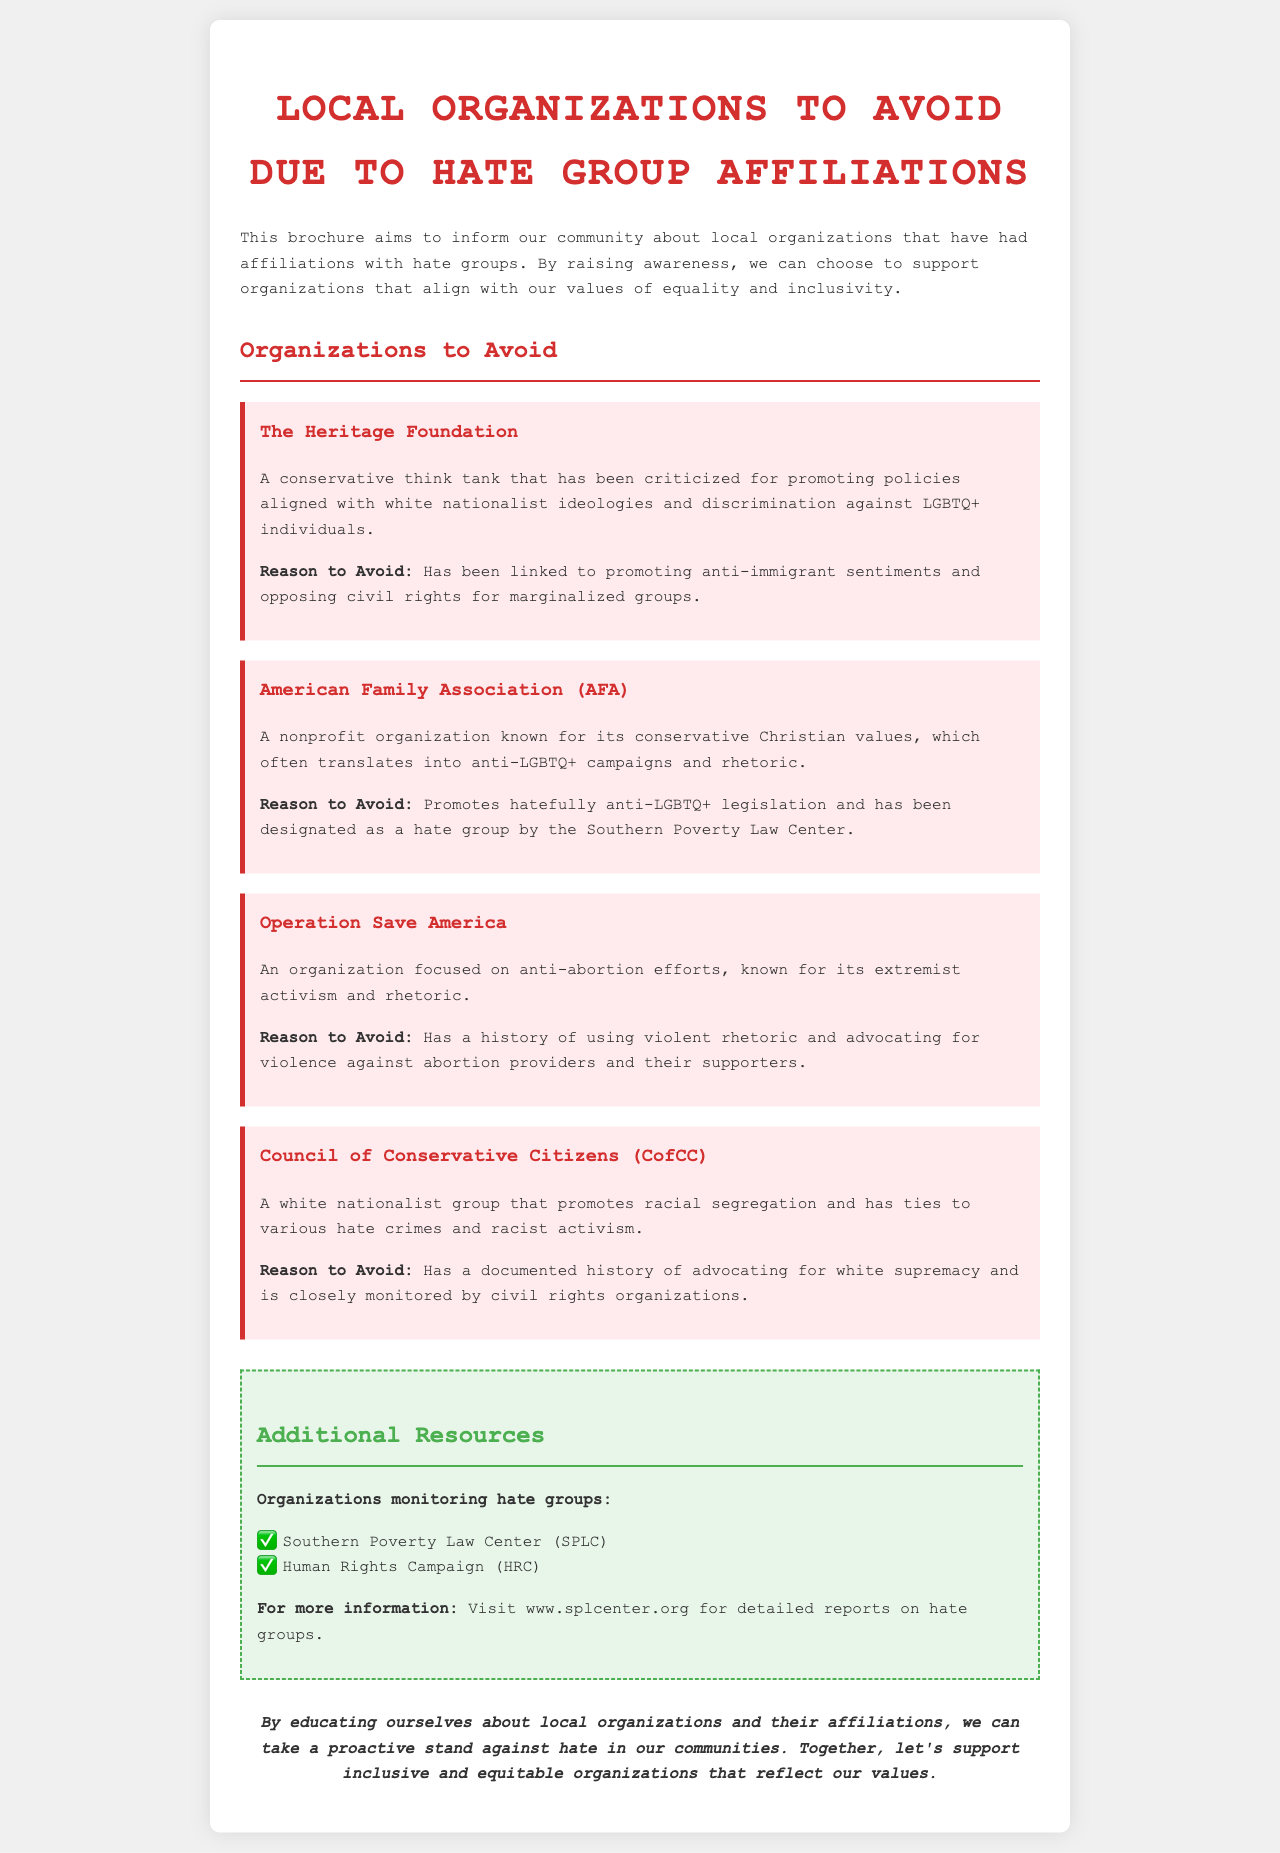What is the title of the brochure? The title is explicitly stated at the beginning of the document.
Answer: Local Organizations to Avoid Due to Hate Group Affiliations What organization is criticized for anti-LGBTQ+ campaigns? This information is found in the section describing specific organizations to avoid.
Answer: American Family Association (AFA) How many organizations are listed to avoid? The number of organizations listed can be counted from the document.
Answer: Four Which organization has a history of advocating for violence against abortion providers? This is referred to in the description of one of the organizations.
Answer: Operation Save America What resource organization is mentioned first? The order of resources is stated under the additional resources section.
Answer: Southern Poverty Law Center (SPLC) What color is the heading for additional resources? The document specifies the color of the heading for this section.
Answer: Green What does the brochure aim to inform the community about? The objective of the brochure is outlined in the introductory paragraph.
Answer: Local organizations with hate group affiliations What is the main reason to avoid The Heritage Foundation? The reason is provided in the description of the organization.
Answer: Promoting anti-immigrant sentiments What is the overall conclusion of the brochure? The conclusion is summarized in the last paragraph of the document.
Answer: Support inclusive and equitable organizations 